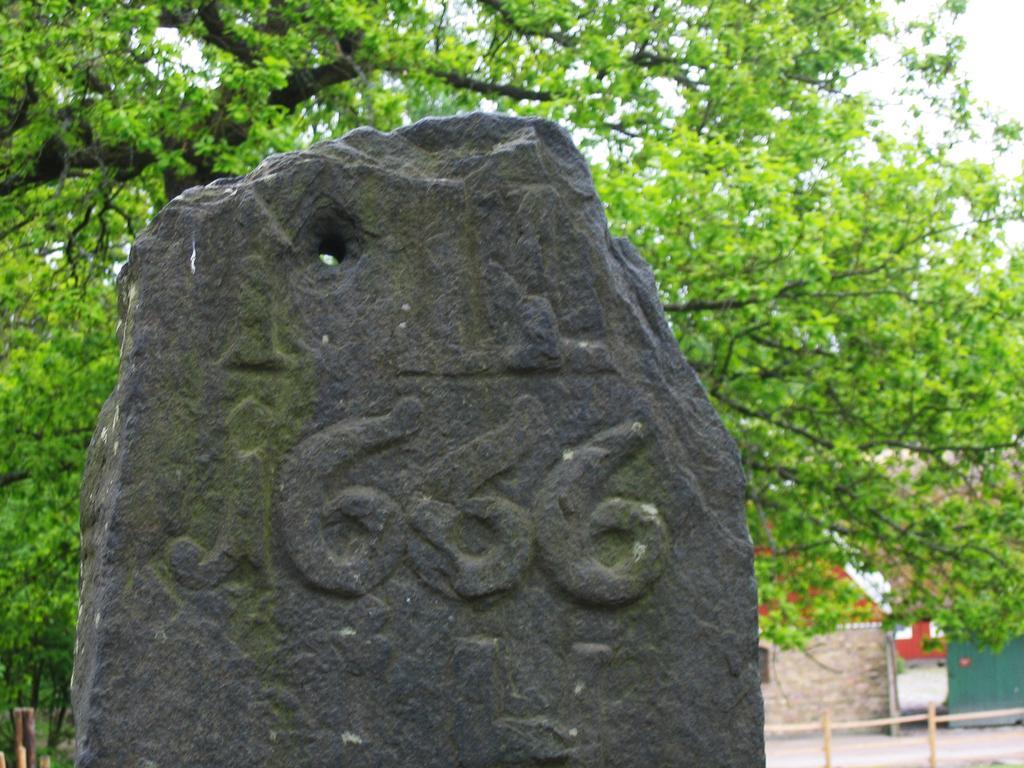Describe this image in one or two sentences. This is a stone and there is a wall. In the background we can see trees and sky. 